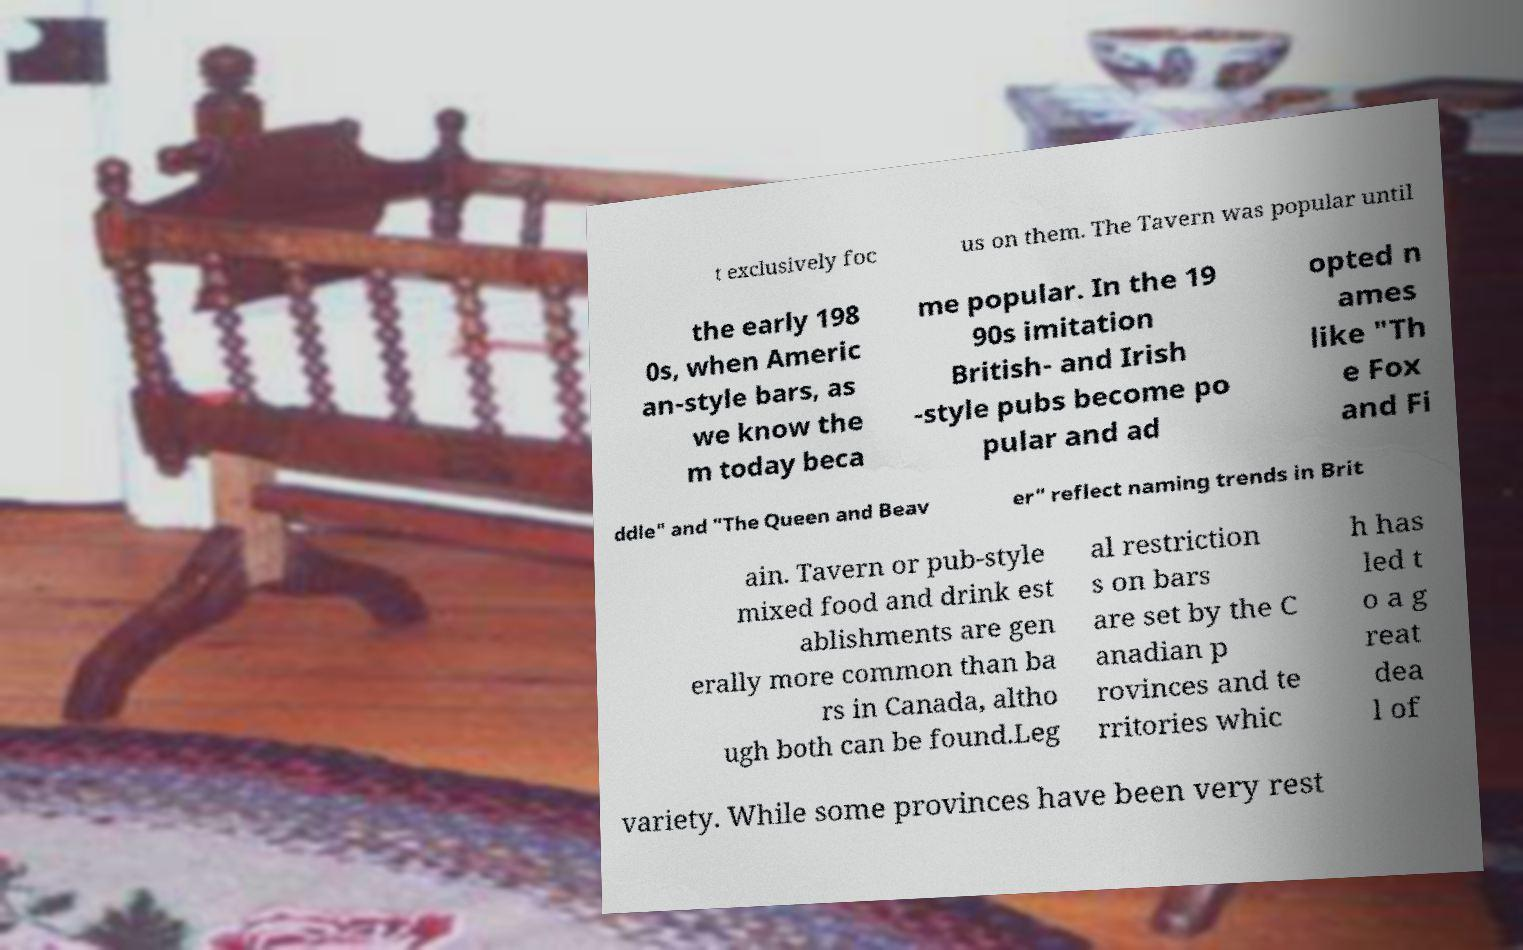What messages or text are displayed in this image? I need them in a readable, typed format. t exclusively foc us on them. The Tavern was popular until the early 198 0s, when Americ an-style bars, as we know the m today beca me popular. In the 19 90s imitation British- and Irish -style pubs become po pular and ad opted n ames like "Th e Fox and Fi ddle" and "The Queen and Beav er" reflect naming trends in Brit ain. Tavern or pub-style mixed food and drink est ablishments are gen erally more common than ba rs in Canada, altho ugh both can be found.Leg al restriction s on bars are set by the C anadian p rovinces and te rritories whic h has led t o a g reat dea l of variety. While some provinces have been very rest 